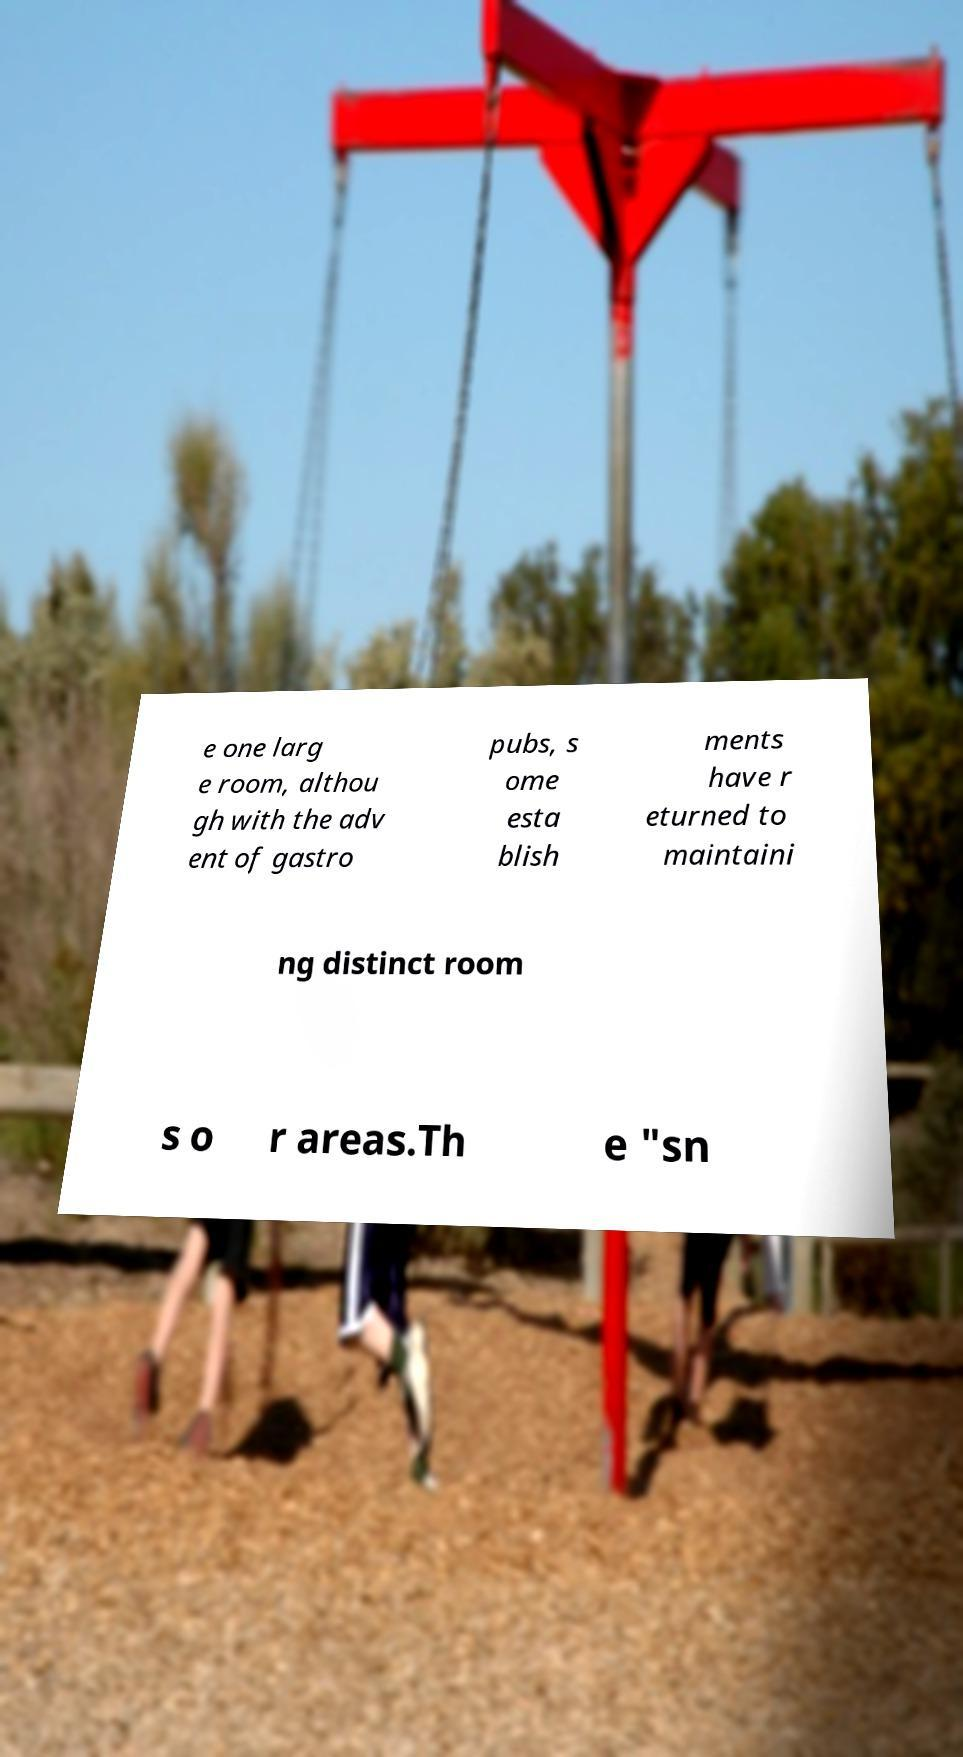Can you accurately transcribe the text from the provided image for me? e one larg e room, althou gh with the adv ent of gastro pubs, s ome esta blish ments have r eturned to maintaini ng distinct room s o r areas.Th e "sn 